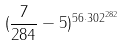<formula> <loc_0><loc_0><loc_500><loc_500>( \frac { 7 } { 2 8 4 } - 5 ) ^ { 5 6 \cdot 3 0 2 ^ { 2 8 2 } }</formula> 